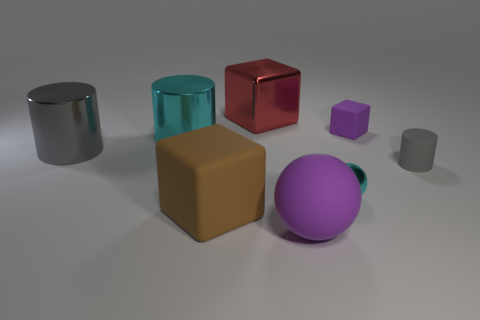Are there any small yellow matte objects?
Offer a very short reply. No. How many other objects are the same size as the red object?
Give a very brief answer. 4. There is a large matte ball; is its color the same as the tiny thing behind the large cyan metal cylinder?
Offer a terse response. Yes. How many things are small cylinders or shiny things?
Ensure brevity in your answer.  5. Are there any other things that have the same color as the metallic sphere?
Provide a short and direct response. Yes. Is the material of the tiny cyan thing the same as the small thing that is behind the small matte cylinder?
Make the answer very short. No. The purple rubber thing that is in front of the block that is right of the large purple object is what shape?
Your answer should be very brief. Sphere. The thing that is both on the left side of the large purple object and behind the big cyan shiny cylinder has what shape?
Provide a succinct answer. Cube. How many things are blue matte cubes or big matte objects that are in front of the large rubber cube?
Give a very brief answer. 1. What is the material of the big cyan thing that is the same shape as the big gray thing?
Your answer should be compact. Metal. 